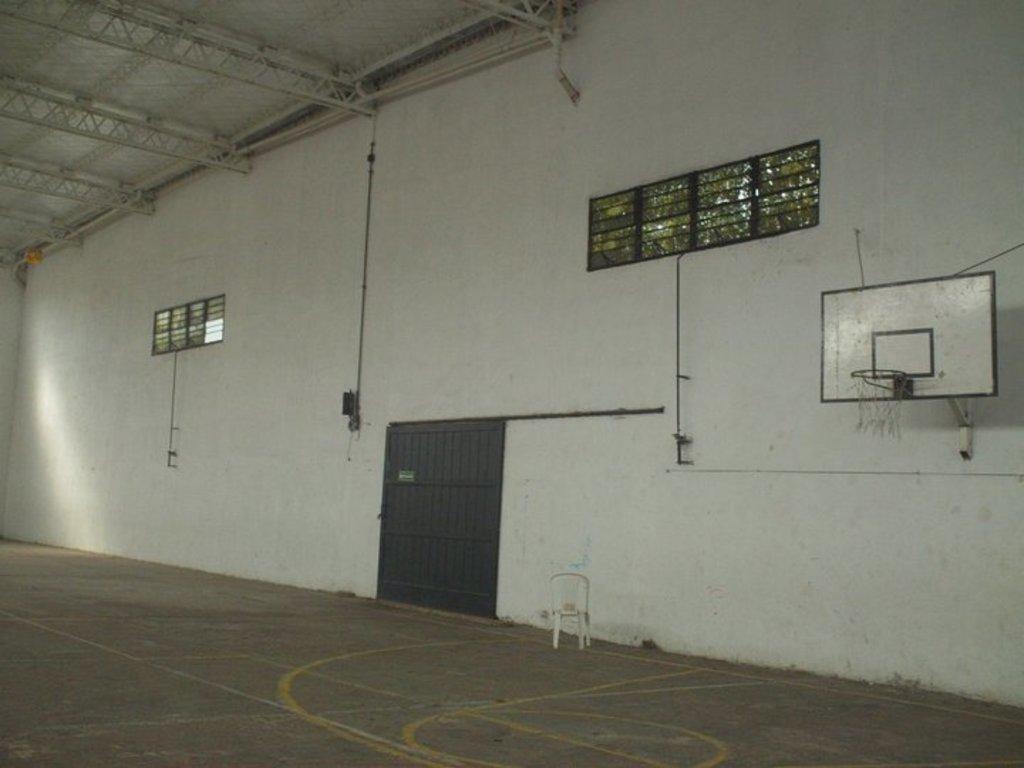How would you summarize this image in a sentence or two? This is a court and here we can see a chair, door, windows and hoop. In the background, there is a wall and at the top, there is roof. At the bottom, there is floor. 